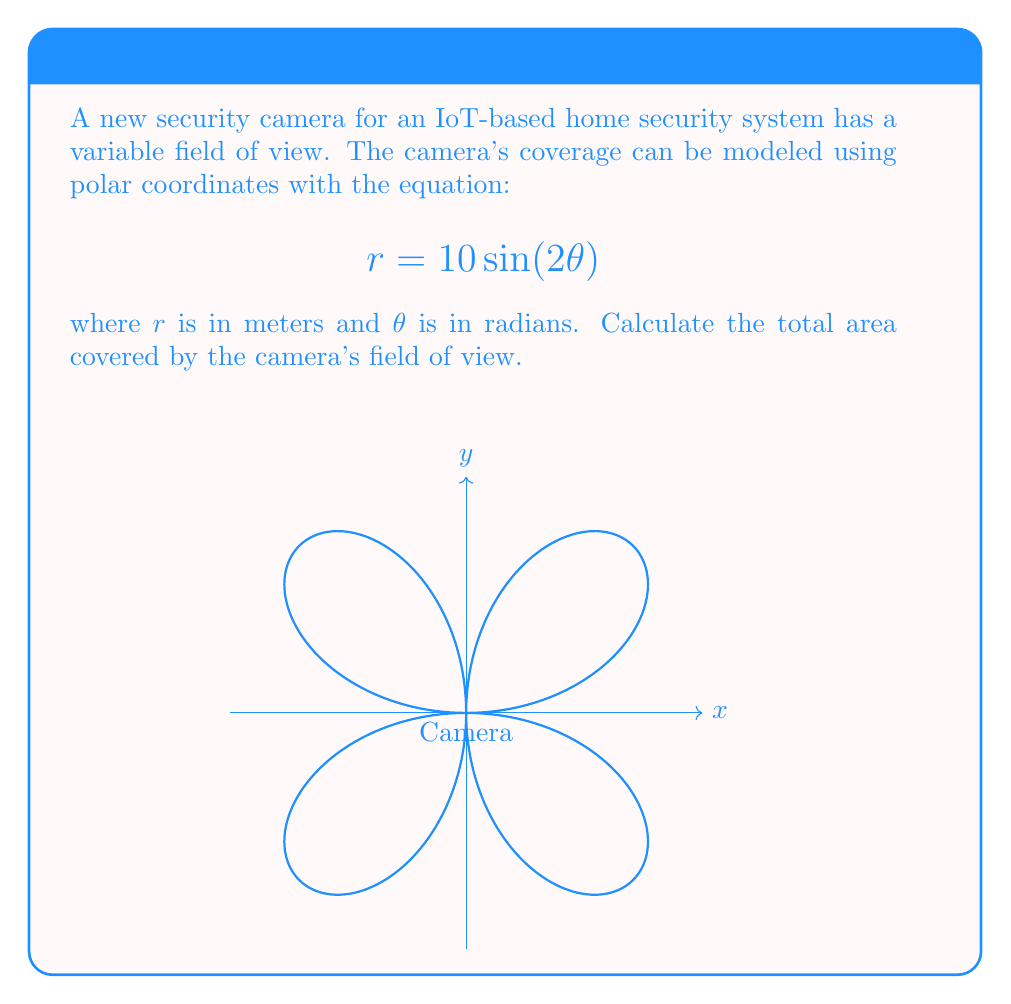Help me with this question. To solve this problem, we'll follow these steps:

1) The area of a region in polar coordinates is given by the formula:

   $$A = \frac{1}{2} \int_a^b r^2(\theta) d\theta$$

2) In this case, $r(\theta) = 10 \sin(2\theta)$, so $r^2(\theta) = 100 \sin^2(2\theta)$

3) We need to determine the limits of integration. The function repeats every $\pi$ radians, so we'll integrate from 0 to $\pi$:

   $$A = \frac{1}{2} \int_0^\pi 100 \sin^2(2\theta) d\theta$$

4) Simplify:

   $$A = 50 \int_0^\pi \sin^2(2\theta) d\theta$$

5) Use the trigonometric identity $\sin^2(x) = \frac{1 - \cos(2x)}{2}$:

   $$A = 50 \int_0^\pi \frac{1 - \cos(4\theta)}{2} d\theta$$

6) Simplify:

   $$A = 25 \int_0^\pi (1 - \cos(4\theta)) d\theta$$

7) Integrate:

   $$A = 25 [\theta - \frac{1}{4}\sin(4\theta)]_0^\pi$$

8) Evaluate the integral:

   $$A = 25 [(\pi - 0) - (\frac{1}{4}\sin(4\pi) - \frac{1}{4}\sin(0))]$$

9) Simplify:

   $$A = 25\pi$$

Therefore, the total area covered by the camera is $25\pi$ square meters.
Answer: $25\pi$ m² 